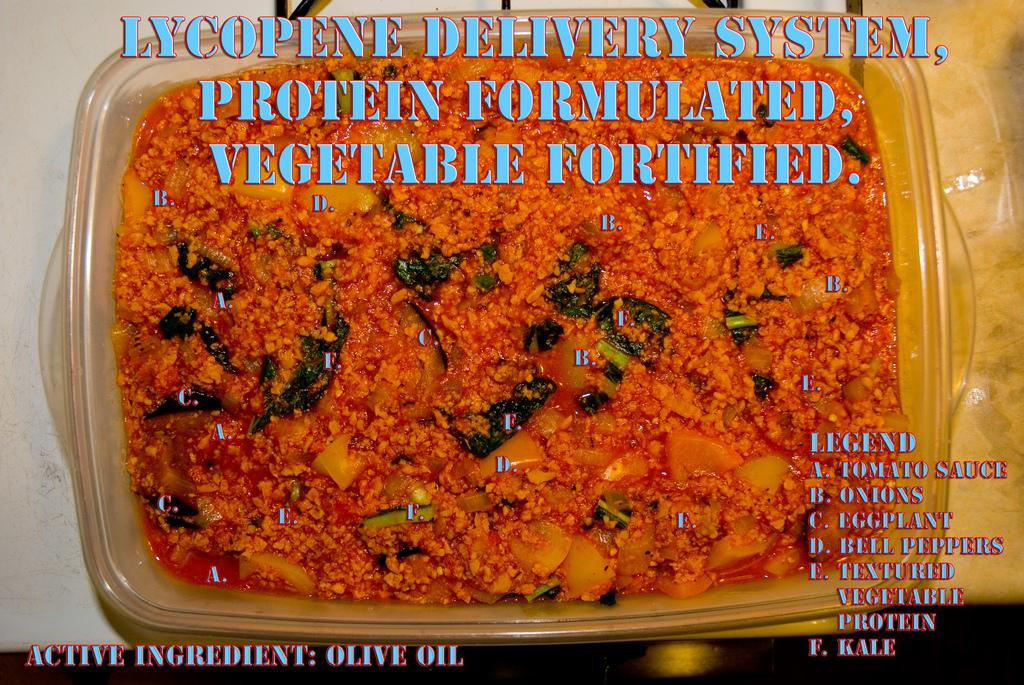What object is present in the image that is made of plastic? There is a plastic box in the image. What is inside the plastic box? The plastic box contains food. Where is the plastic box located in the image? The plastic box is placed on a table. What else can be seen in the image besides the plastic box? There is text in the image. What type of secretary is shown working in the image? There is no secretary present in the image. 